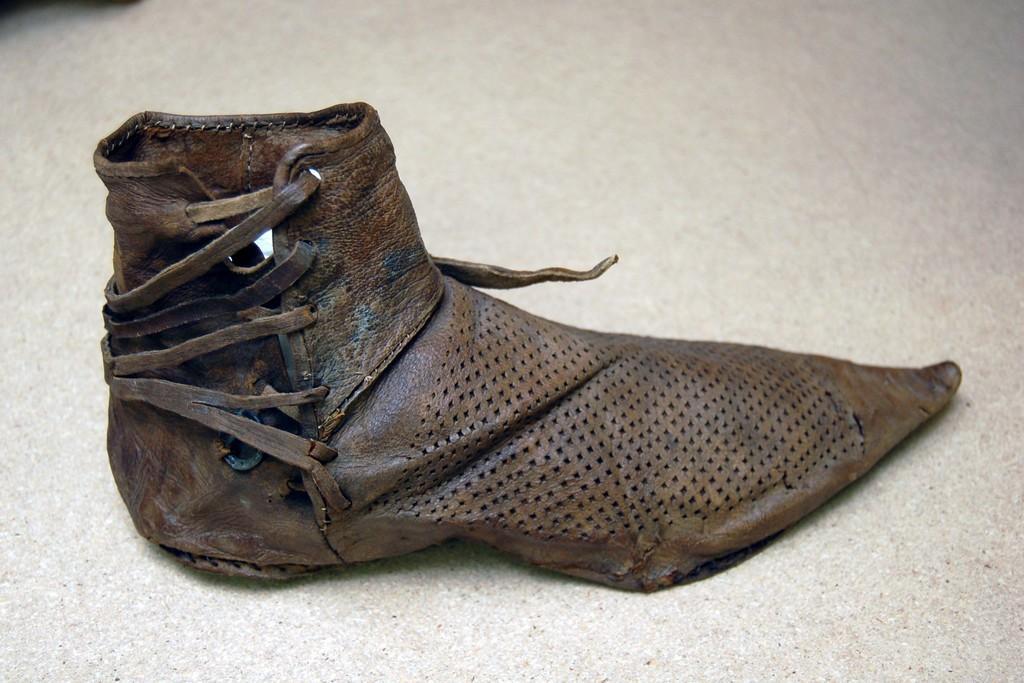Could you give a brief overview of what you see in this image? In this image we can see a leather shoe placed on the white surface. 